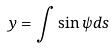<formula> <loc_0><loc_0><loc_500><loc_500>y = \int \sin \psi d s</formula> 